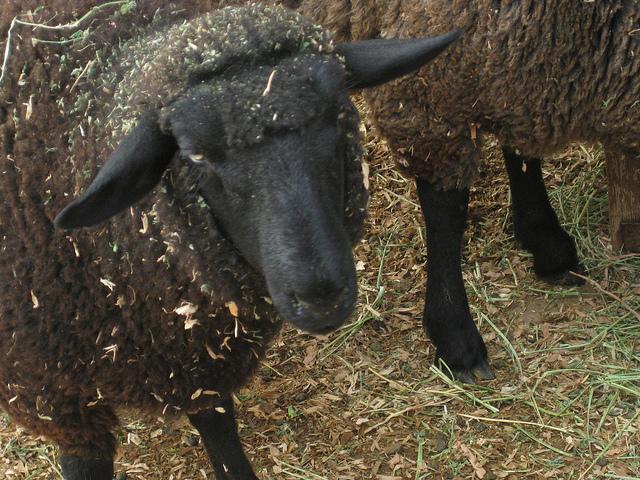What color is the animal's face?
Write a very short answer. Black. What color is the ground?
Write a very short answer. Brown. Have these sheep been freshly sheared?
Be succinct. No. 